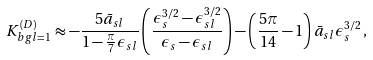Convert formula to latex. <formula><loc_0><loc_0><loc_500><loc_500>K ^ { ( D ) } _ { b g l = 1 } \approx - \frac { 5 \bar { a } _ { s l } } { 1 - \frac { \pi } { 7 } \epsilon _ { s l } } \left ( \frac { \epsilon _ { s } ^ { 3 / 2 } - \epsilon _ { s l } ^ { 3 / 2 } } { \epsilon _ { s } - \epsilon _ { s l } } \right ) - \left ( \frac { 5 \pi } { 1 4 } - 1 \right ) \bar { a } _ { s l } \epsilon _ { s } ^ { 3 / 2 } \, ,</formula> 